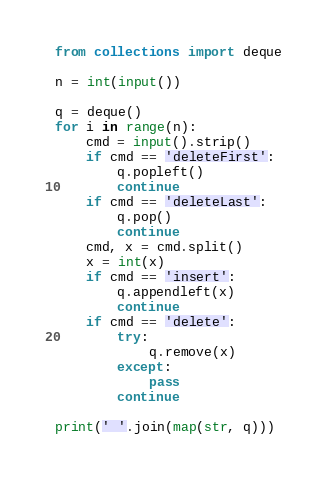<code> <loc_0><loc_0><loc_500><loc_500><_Python_>from collections import deque

n = int(input())

q = deque()
for i in range(n):
    cmd = input().strip()
    if cmd == 'deleteFirst':
        q.popleft()
        continue
    if cmd == 'deleteLast':
        q.pop()
        continue
    cmd, x = cmd.split()
    x = int(x)
    if cmd == 'insert':
        q.appendleft(x)
        continue
    if cmd == 'delete':
        try:
            q.remove(x)
        except:
            pass
        continue

print(' '.join(map(str, q)))</code> 